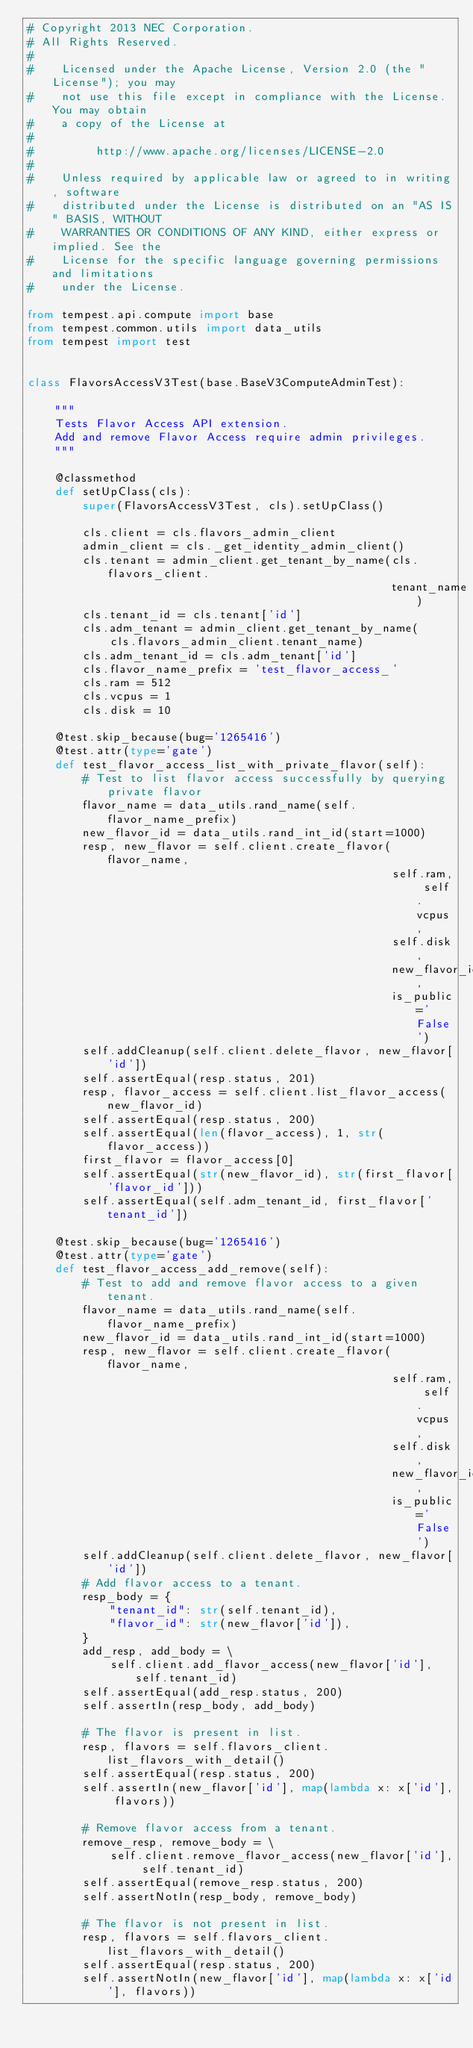Convert code to text. <code><loc_0><loc_0><loc_500><loc_500><_Python_># Copyright 2013 NEC Corporation.
# All Rights Reserved.
#
#    Licensed under the Apache License, Version 2.0 (the "License"); you may
#    not use this file except in compliance with the License. You may obtain
#    a copy of the License at
#
#         http://www.apache.org/licenses/LICENSE-2.0
#
#    Unless required by applicable law or agreed to in writing, software
#    distributed under the License is distributed on an "AS IS" BASIS, WITHOUT
#    WARRANTIES OR CONDITIONS OF ANY KIND, either express or implied. See the
#    License for the specific language governing permissions and limitations
#    under the License.

from tempest.api.compute import base
from tempest.common.utils import data_utils
from tempest import test


class FlavorsAccessV3Test(base.BaseV3ComputeAdminTest):

    """
    Tests Flavor Access API extension.
    Add and remove Flavor Access require admin privileges.
    """

    @classmethod
    def setUpClass(cls):
        super(FlavorsAccessV3Test, cls).setUpClass()

        cls.client = cls.flavors_admin_client
        admin_client = cls._get_identity_admin_client()
        cls.tenant = admin_client.get_tenant_by_name(cls.flavors_client.
                                                     tenant_name)
        cls.tenant_id = cls.tenant['id']
        cls.adm_tenant = admin_client.get_tenant_by_name(
            cls.flavors_admin_client.tenant_name)
        cls.adm_tenant_id = cls.adm_tenant['id']
        cls.flavor_name_prefix = 'test_flavor_access_'
        cls.ram = 512
        cls.vcpus = 1
        cls.disk = 10

    @test.skip_because(bug='1265416')
    @test.attr(type='gate')
    def test_flavor_access_list_with_private_flavor(self):
        # Test to list flavor access successfully by querying private flavor
        flavor_name = data_utils.rand_name(self.flavor_name_prefix)
        new_flavor_id = data_utils.rand_int_id(start=1000)
        resp, new_flavor = self.client.create_flavor(flavor_name,
                                                     self.ram, self.vcpus,
                                                     self.disk,
                                                     new_flavor_id,
                                                     is_public='False')
        self.addCleanup(self.client.delete_flavor, new_flavor['id'])
        self.assertEqual(resp.status, 201)
        resp, flavor_access = self.client.list_flavor_access(new_flavor_id)
        self.assertEqual(resp.status, 200)
        self.assertEqual(len(flavor_access), 1, str(flavor_access))
        first_flavor = flavor_access[0]
        self.assertEqual(str(new_flavor_id), str(first_flavor['flavor_id']))
        self.assertEqual(self.adm_tenant_id, first_flavor['tenant_id'])

    @test.skip_because(bug='1265416')
    @test.attr(type='gate')
    def test_flavor_access_add_remove(self):
        # Test to add and remove flavor access to a given tenant.
        flavor_name = data_utils.rand_name(self.flavor_name_prefix)
        new_flavor_id = data_utils.rand_int_id(start=1000)
        resp, new_flavor = self.client.create_flavor(flavor_name,
                                                     self.ram, self.vcpus,
                                                     self.disk,
                                                     new_flavor_id,
                                                     is_public='False')
        self.addCleanup(self.client.delete_flavor, new_flavor['id'])
        # Add flavor access to a tenant.
        resp_body = {
            "tenant_id": str(self.tenant_id),
            "flavor_id": str(new_flavor['id']),
        }
        add_resp, add_body = \
            self.client.add_flavor_access(new_flavor['id'], self.tenant_id)
        self.assertEqual(add_resp.status, 200)
        self.assertIn(resp_body, add_body)

        # The flavor is present in list.
        resp, flavors = self.flavors_client.list_flavors_with_detail()
        self.assertEqual(resp.status, 200)
        self.assertIn(new_flavor['id'], map(lambda x: x['id'], flavors))

        # Remove flavor access from a tenant.
        remove_resp, remove_body = \
            self.client.remove_flavor_access(new_flavor['id'], self.tenant_id)
        self.assertEqual(remove_resp.status, 200)
        self.assertNotIn(resp_body, remove_body)

        # The flavor is not present in list.
        resp, flavors = self.flavors_client.list_flavors_with_detail()
        self.assertEqual(resp.status, 200)
        self.assertNotIn(new_flavor['id'], map(lambda x: x['id'], flavors))
</code> 